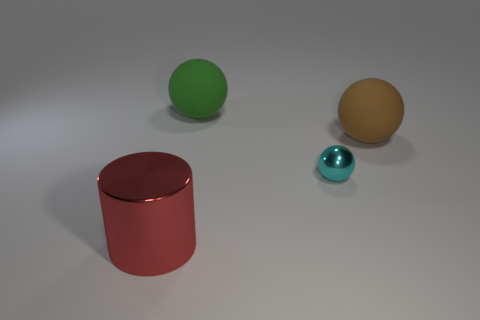Is the material of the green object the same as the cyan thing that is to the right of the large green object?
Provide a succinct answer. No. What material is the large object in front of the tiny cyan metallic sphere?
Keep it short and to the point. Metal. There is a rubber thing that is on the right side of the small cyan metal object; is its shape the same as the small cyan metal thing?
Offer a very short reply. Yes. There is a big brown matte object; are there any tiny metallic things to the left of it?
Give a very brief answer. Yes. How many large things are either blocks or cyan balls?
Provide a short and direct response. 0. Is the tiny cyan thing made of the same material as the red thing?
Make the answer very short. Yes. There is a green object that is made of the same material as the brown thing; what is its size?
Keep it short and to the point. Large. There is a large thing on the left side of the rubber ball to the left of the sphere right of the small cyan ball; what is its shape?
Offer a terse response. Cylinder. The green rubber object that is the same shape as the small metal thing is what size?
Provide a succinct answer. Large. There is a thing that is both in front of the brown object and behind the big red shiny thing; what size is it?
Offer a very short reply. Small. 